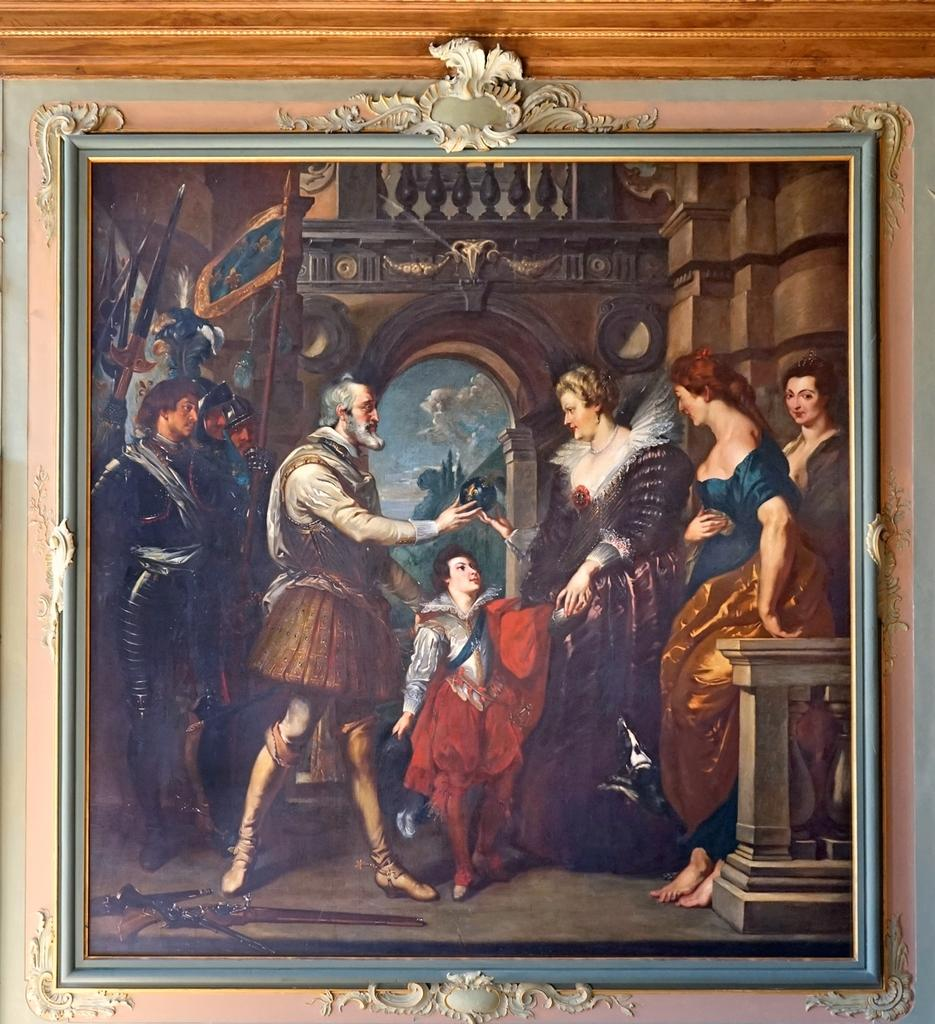What is the main subject of the image? The main subject of the image is a painting. What types of people are depicted in the painting? There are men, women, and a girl in the painting. What type of berry is being used to paint the girl's hair in the image? There is no indication in the image that any berries were used to create the painting, and the girl's hair is not made of berries. 